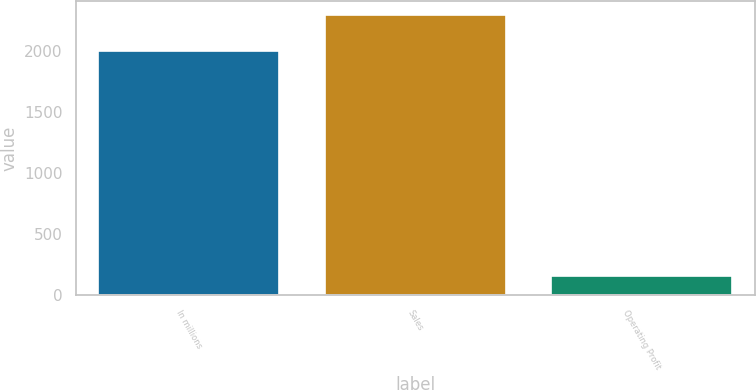<chart> <loc_0><loc_0><loc_500><loc_500><bar_chart><fcel>In millions<fcel>Sales<fcel>Operating Profit<nl><fcel>2004<fcel>2295<fcel>155<nl></chart> 